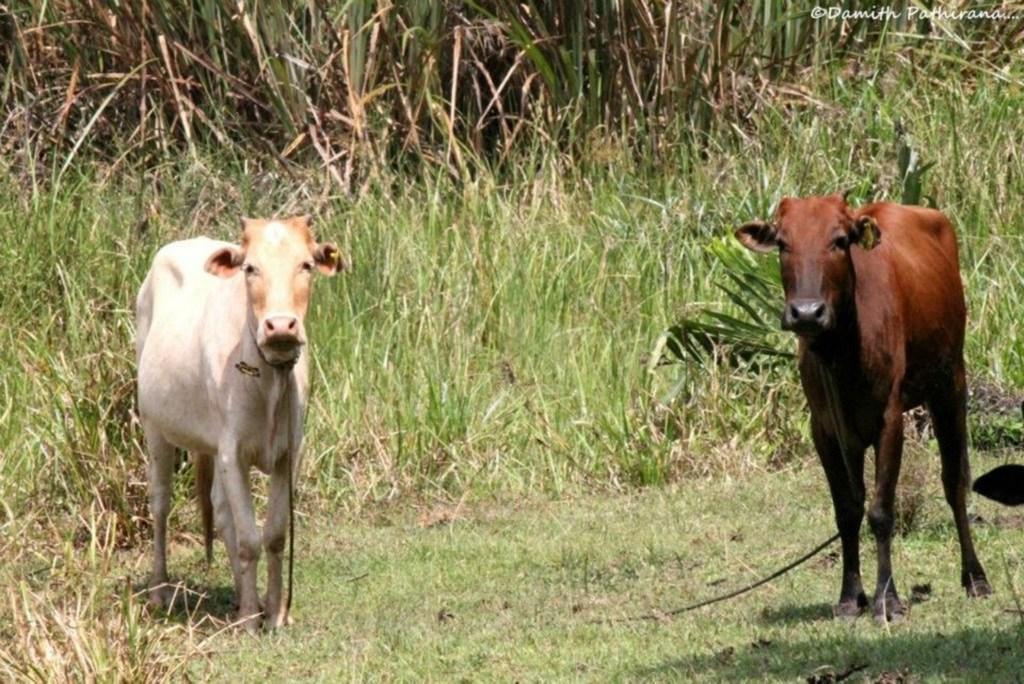How would you summarize this image in a sentence or two? Here there are two cows,in the back there are plants which are of green color and here there is rope. 